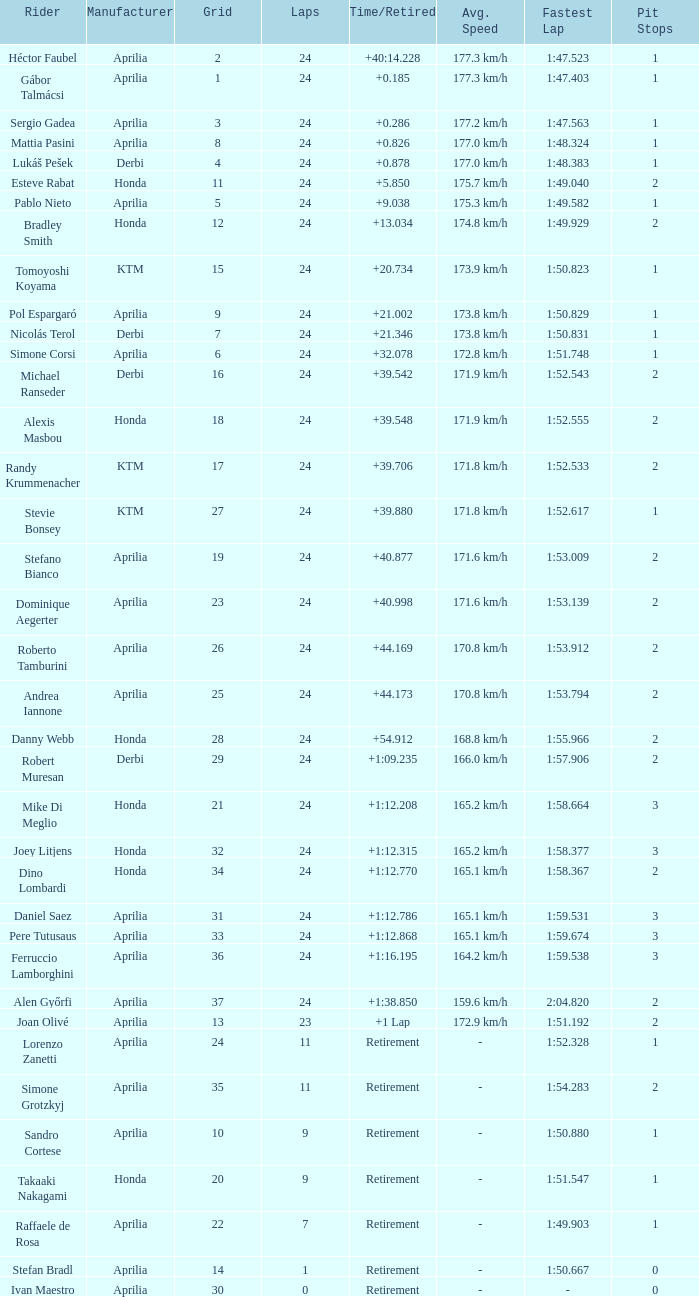How many grids correspond to more than 24 laps? None. 